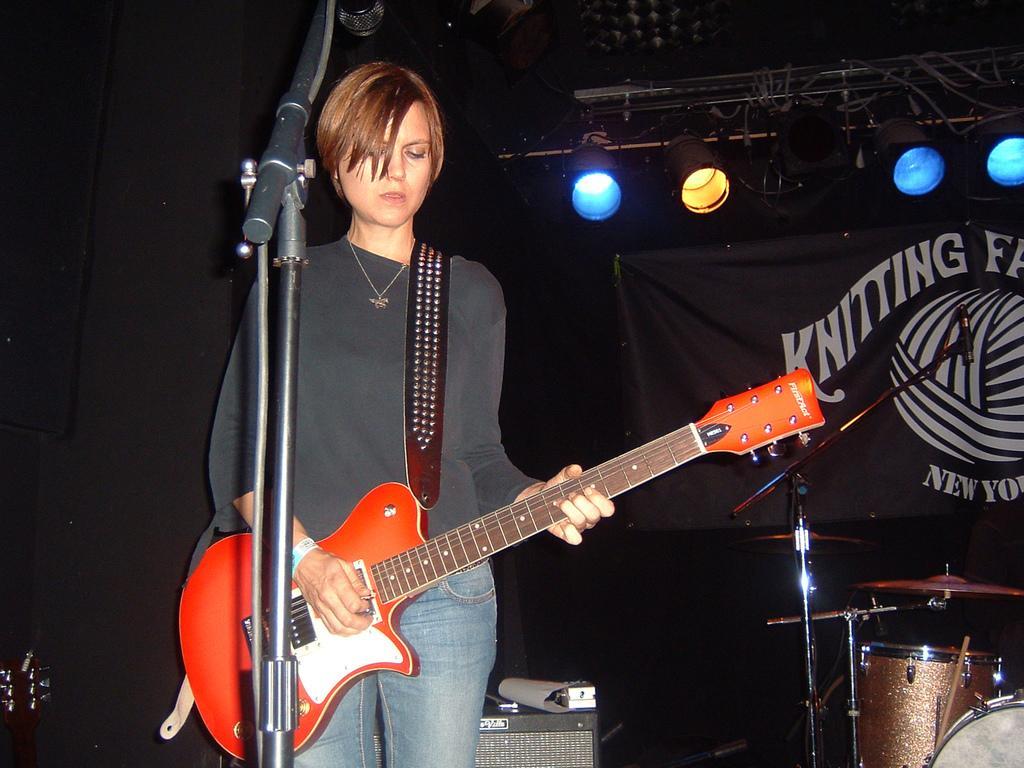How would you summarize this image in a sentence or two? this picture shows a woman standing and holding a guitar in her hand and we see a microphone in front of her and we see drums and few lights on the top 